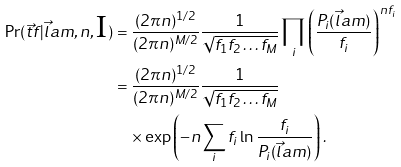Convert formula to latex. <formula><loc_0><loc_0><loc_500><loc_500>\Pr ( \vec { t } { f } | \vec { l } a m , n , \text {I} ) & = \frac { ( 2 \pi n ) ^ { 1 / 2 } } { ( 2 \pi n ) ^ { M / 2 } } \frac { 1 } { \sqrt { f _ { 1 } f _ { 2 } \dots f _ { M } } } \prod _ { i } \left ( \frac { P _ { i } ( \vec { l } a m ) } { f _ { i } } \right ) ^ { n f _ { i } } \\ & = \frac { ( 2 \pi n ) ^ { 1 / 2 } } { ( 2 \pi n ) ^ { M / 2 } } \frac { 1 } { \sqrt { f _ { 1 } f _ { 2 } \dots f _ { M } } } \\ & \quad \times \exp \left ( - n \sum _ { i } f _ { i } \ln \frac { f _ { i } } { P _ { i } ( \vec { l } a m ) } \right ) . \\</formula> 